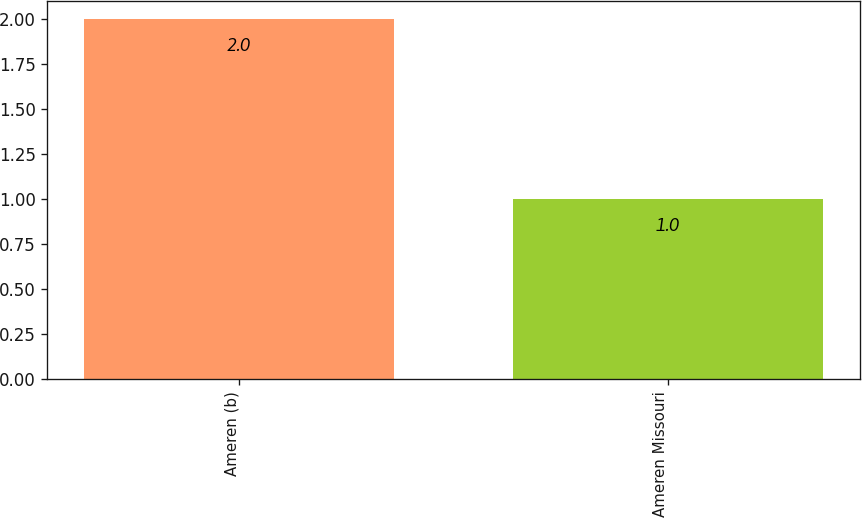Convert chart to OTSL. <chart><loc_0><loc_0><loc_500><loc_500><bar_chart><fcel>Ameren (b)<fcel>Ameren Missouri<nl><fcel>2<fcel>1<nl></chart> 